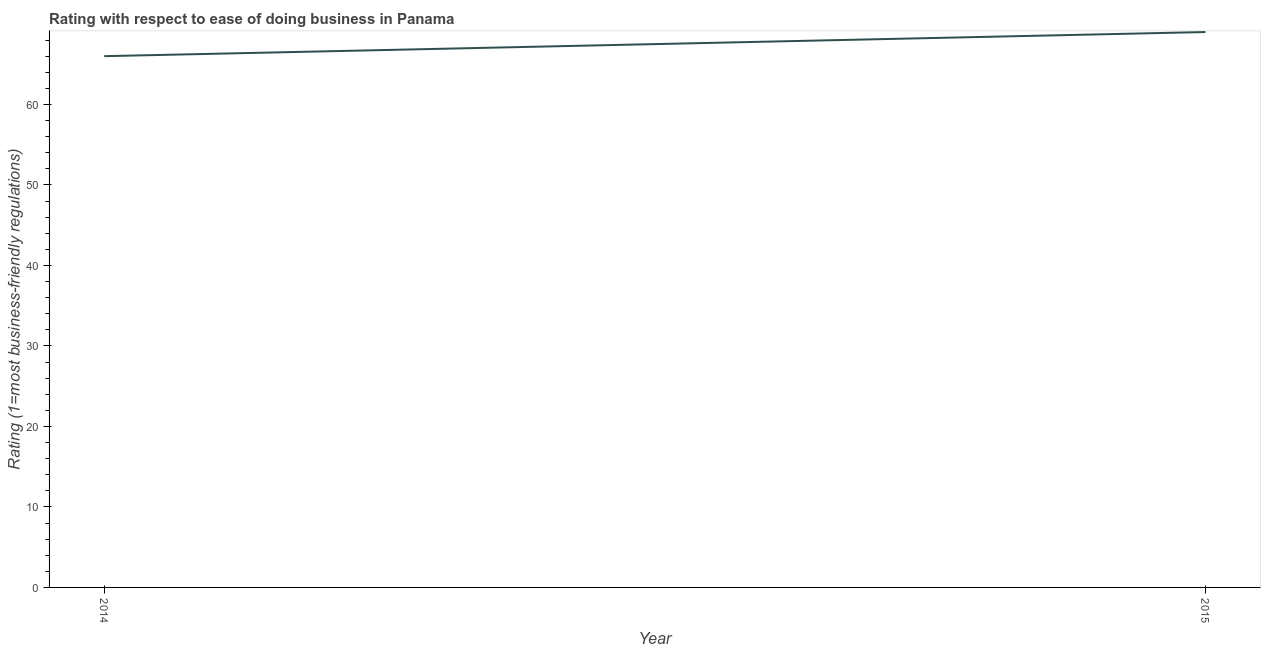What is the ease of doing business index in 2015?
Your response must be concise. 69. Across all years, what is the maximum ease of doing business index?
Give a very brief answer. 69. Across all years, what is the minimum ease of doing business index?
Make the answer very short. 66. In which year was the ease of doing business index maximum?
Provide a succinct answer. 2015. In which year was the ease of doing business index minimum?
Your response must be concise. 2014. What is the sum of the ease of doing business index?
Your answer should be very brief. 135. What is the difference between the ease of doing business index in 2014 and 2015?
Provide a succinct answer. -3. What is the average ease of doing business index per year?
Ensure brevity in your answer.  67.5. What is the median ease of doing business index?
Your answer should be very brief. 67.5. In how many years, is the ease of doing business index greater than 50 ?
Your answer should be very brief. 2. Do a majority of the years between 2015 and 2014 (inclusive) have ease of doing business index greater than 30 ?
Your response must be concise. No. What is the ratio of the ease of doing business index in 2014 to that in 2015?
Your answer should be compact. 0.96. Is the ease of doing business index in 2014 less than that in 2015?
Ensure brevity in your answer.  Yes. Does the ease of doing business index monotonically increase over the years?
Make the answer very short. Yes. How many lines are there?
Give a very brief answer. 1. How many years are there in the graph?
Make the answer very short. 2. Are the values on the major ticks of Y-axis written in scientific E-notation?
Your answer should be compact. No. Does the graph contain any zero values?
Your answer should be very brief. No. What is the title of the graph?
Offer a terse response. Rating with respect to ease of doing business in Panama. What is the label or title of the Y-axis?
Provide a succinct answer. Rating (1=most business-friendly regulations). What is the Rating (1=most business-friendly regulations) in 2014?
Make the answer very short. 66. What is the difference between the Rating (1=most business-friendly regulations) in 2014 and 2015?
Provide a succinct answer. -3. 